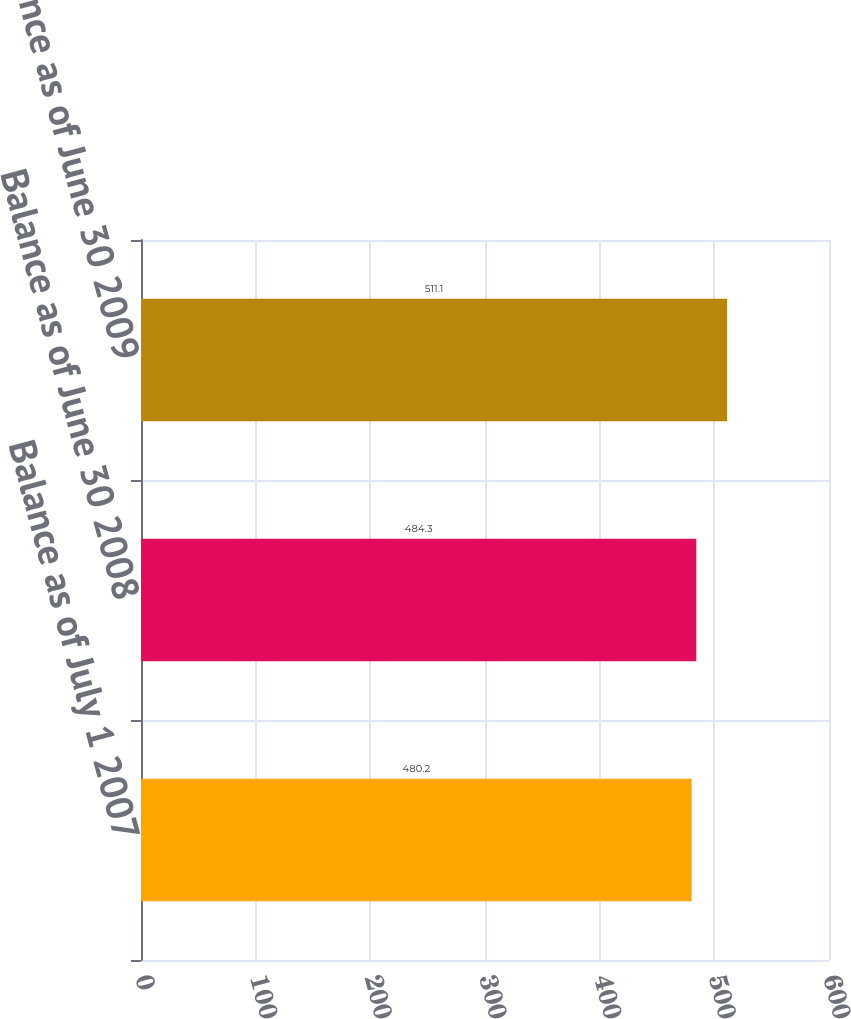Convert chart to OTSL. <chart><loc_0><loc_0><loc_500><loc_500><bar_chart><fcel>Balance as of July 1 2007<fcel>Balance as of June 30 2008<fcel>Balance as of June 30 2009<nl><fcel>480.2<fcel>484.3<fcel>511.1<nl></chart> 